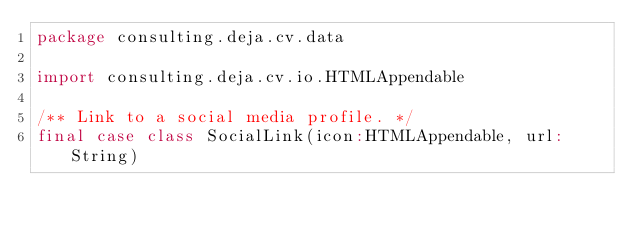Convert code to text. <code><loc_0><loc_0><loc_500><loc_500><_Scala_>package consulting.deja.cv.data

import consulting.deja.cv.io.HTMLAppendable

/** Link to a social media profile. */
final case class SocialLink(icon:HTMLAppendable, url:String)
</code> 